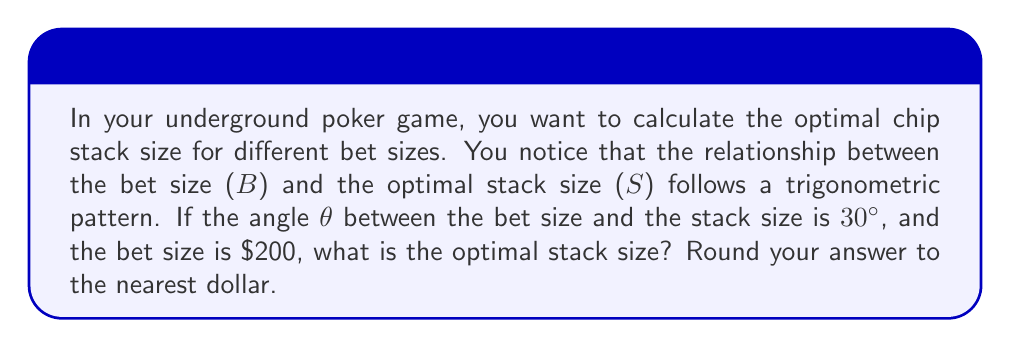Could you help me with this problem? To solve this problem, we need to use trigonometric ratios, specifically the tangent function. Let's break it down step-by-step:

1) In a right-angled triangle, tan(θ) is the ratio of the opposite side to the adjacent side.

2) In our case:
   - θ = 30°
   - The bet size (B) represents the opposite side
   - The stack size (S) represents the hypotenuse

3) We can set up the equation:

   $$\tan(30°) = \frac{B}{S \cos(30°)}$$

4) We know that $\tan(30°) = \frac{1}{\sqrt{3}}$ and $\cos(30°) = \frac{\sqrt{3}}{2}$

5) Substituting these values and the bet size:

   $$\frac{1}{\sqrt{3}} = \frac{200}{S \cdot \frac{\sqrt{3}}{2}}$$

6) Simplifying:

   $$\frac{1}{\sqrt{3}} = \frac{400\sqrt{3}}{3S}$$

7) Cross-multiplying:

   $$3S = 400\sqrt{3}\sqrt{3} = 400 \cdot 3 = 1200$$

8) Solving for S:

   $$S = \frac{1200}{3} = 400$$

Therefore, the optimal stack size is $400.
Answer: $400 